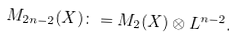<formula> <loc_0><loc_0><loc_500><loc_500>M _ { 2 n - 2 } ( X ) \colon = M _ { 2 } ( X ) \otimes { L } ^ { n - 2 } .</formula> 